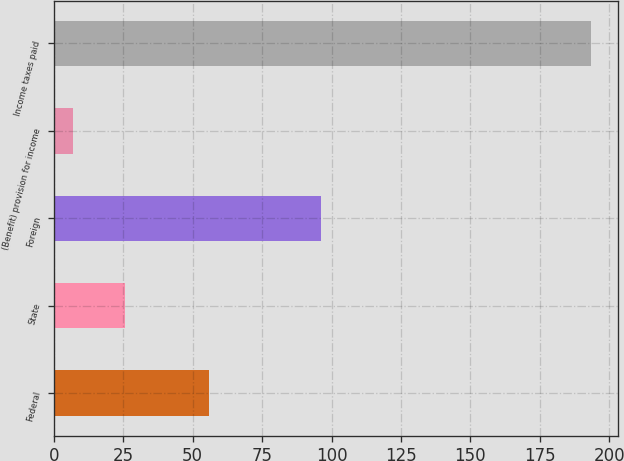<chart> <loc_0><loc_0><loc_500><loc_500><bar_chart><fcel>Federal<fcel>State<fcel>Foreign<fcel>(Benefit) provision for income<fcel>Income taxes paid<nl><fcel>55.8<fcel>25.66<fcel>96.3<fcel>7<fcel>193.6<nl></chart> 